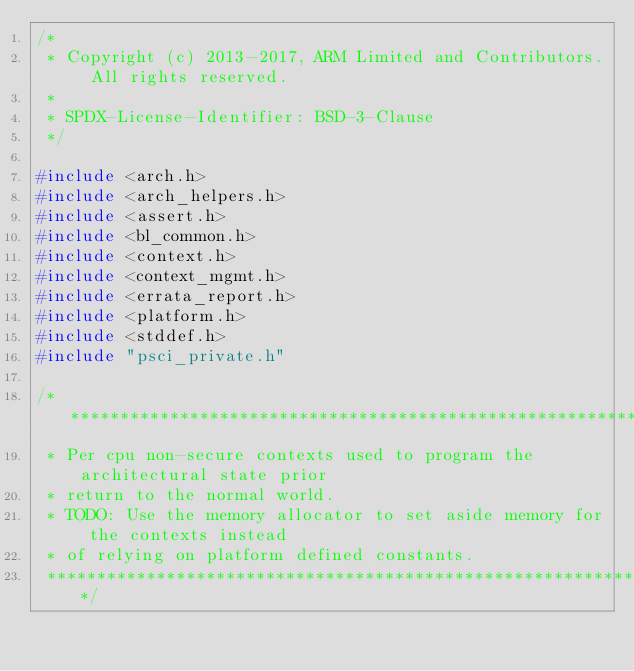<code> <loc_0><loc_0><loc_500><loc_500><_C_>/*
 * Copyright (c) 2013-2017, ARM Limited and Contributors. All rights reserved.
 *
 * SPDX-License-Identifier: BSD-3-Clause
 */

#include <arch.h>
#include <arch_helpers.h>
#include <assert.h>
#include <bl_common.h>
#include <context.h>
#include <context_mgmt.h>
#include <errata_report.h>
#include <platform.h>
#include <stddef.h>
#include "psci_private.h"

/*******************************************************************************
 * Per cpu non-secure contexts used to program the architectural state prior
 * return to the normal world.
 * TODO: Use the memory allocator to set aside memory for the contexts instead
 * of relying on platform defined constants.
 ******************************************************************************/</code> 